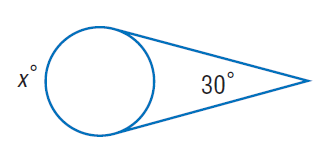Question: Find x. Assume that any segment that appears to be tangent is tangent.
Choices:
A. 30
B. 120
C. 150
D. 210
Answer with the letter. Answer: D 